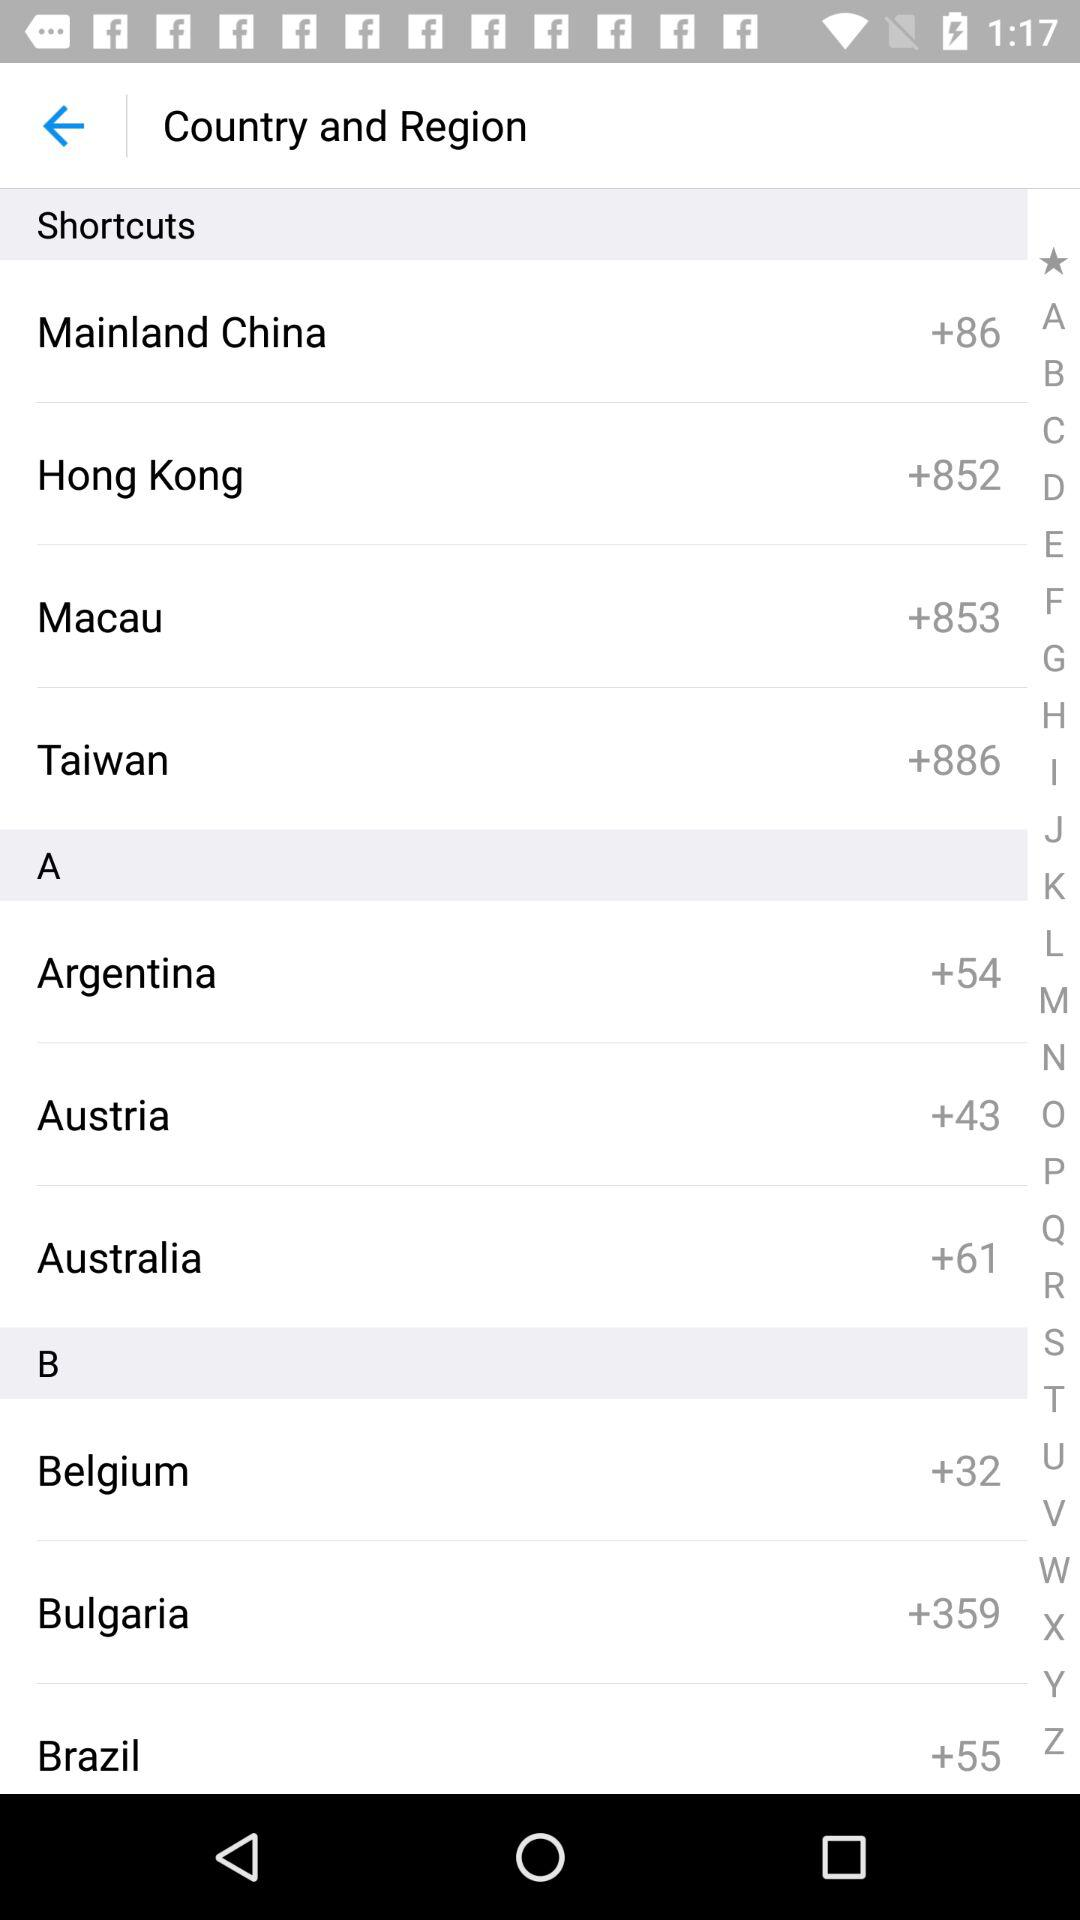What is the country code for Belgium? The country code for Belgium is +32. 